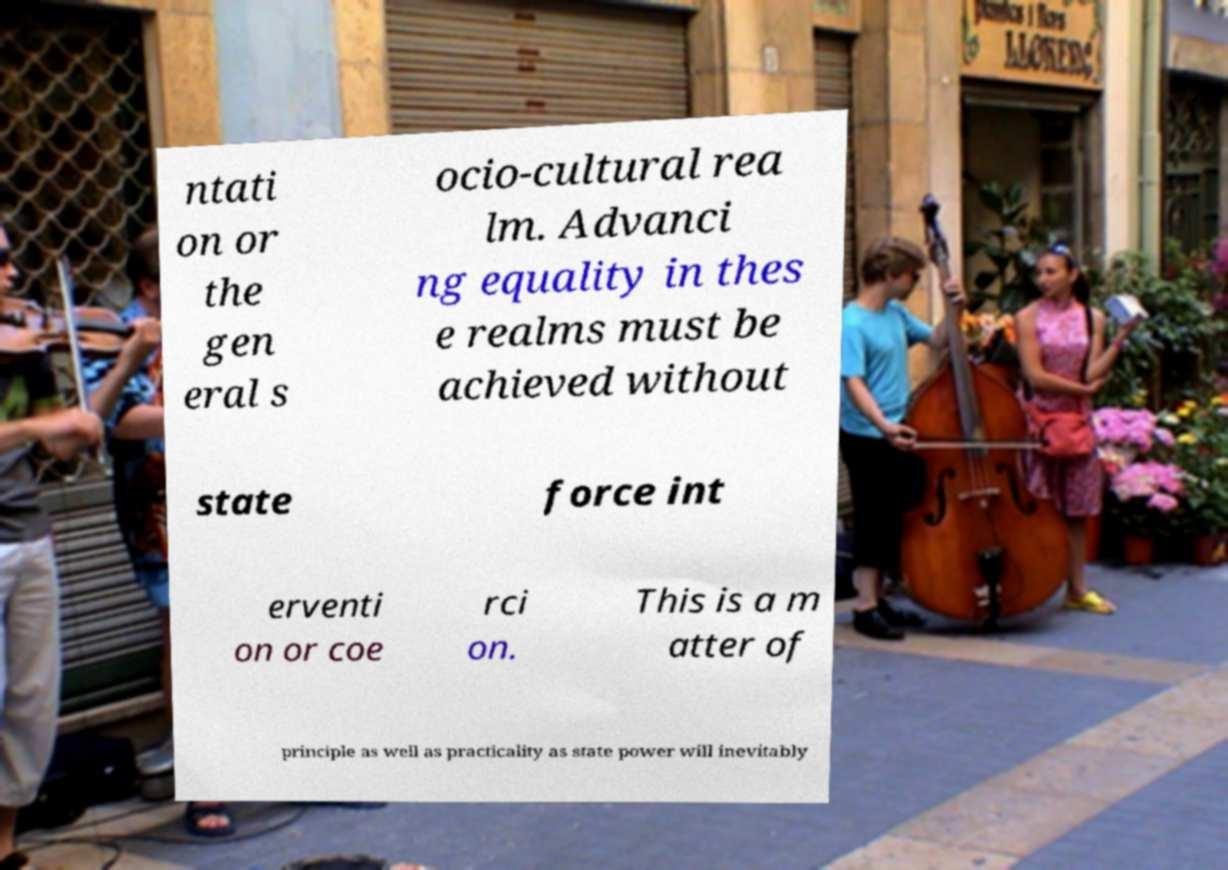Can you accurately transcribe the text from the provided image for me? ntati on or the gen eral s ocio-cultural rea lm. Advanci ng equality in thes e realms must be achieved without state force int erventi on or coe rci on. This is a m atter of principle as well as practicality as state power will inevitably 